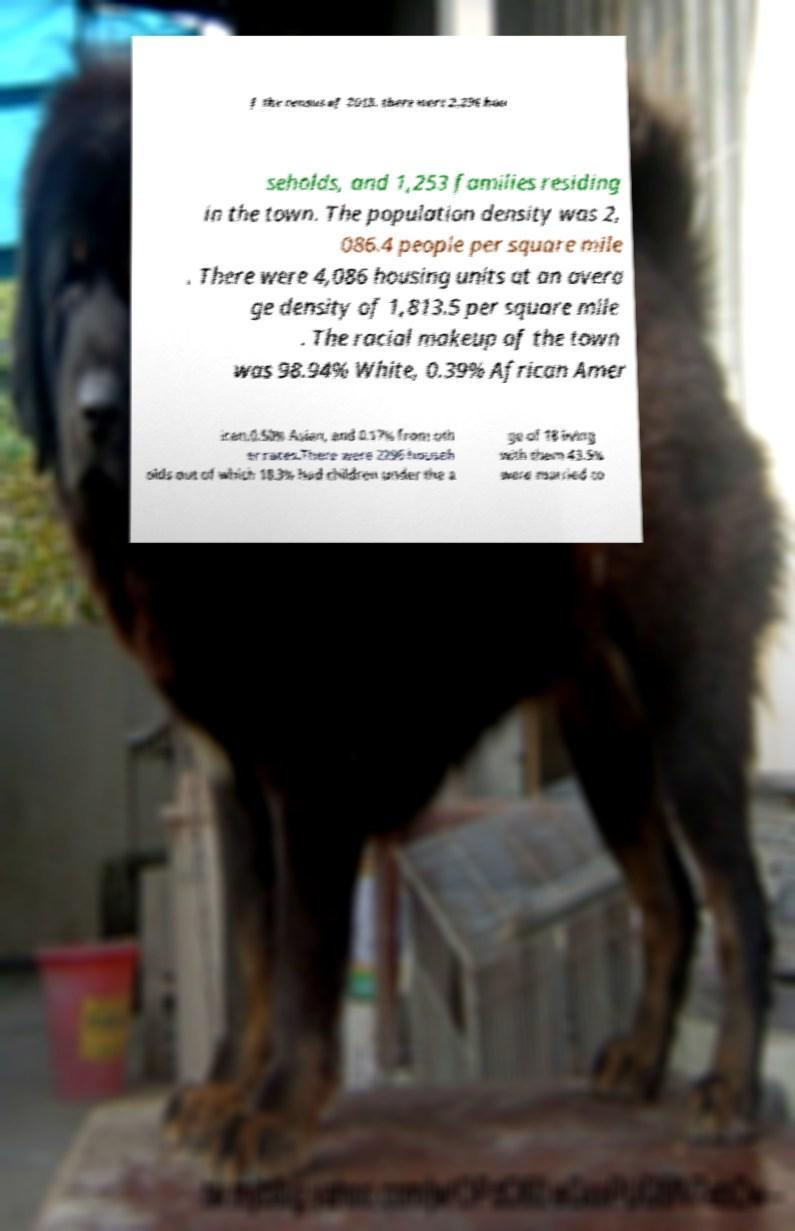Could you assist in decoding the text presented in this image and type it out clearly? f the census of 2013, there were 2,296 hou seholds, and 1,253 families residing in the town. The population density was 2, 086.4 people per square mile . There were 4,086 housing units at an avera ge density of 1,813.5 per square mile . The racial makeup of the town was 98.94% White, 0.39% African Amer ican,0.50% Asian, and 0.17% from oth er races.There were 2296 househ olds out of which 18.3% had children under the a ge of 18 living with them 43.5% were married co 